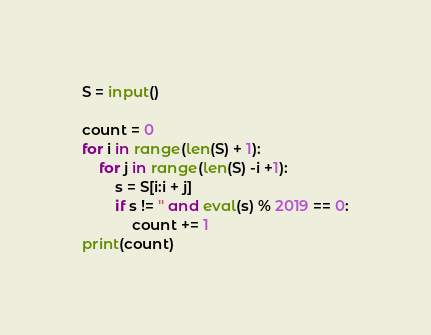Convert code to text. <code><loc_0><loc_0><loc_500><loc_500><_Python_>S = input()

count = 0
for i in range(len(S) + 1):
    for j in range(len(S) -i +1):
        s = S[i:i + j]
        if s != '' and eval(s) % 2019 == 0:
            count += 1
print(count)
</code> 